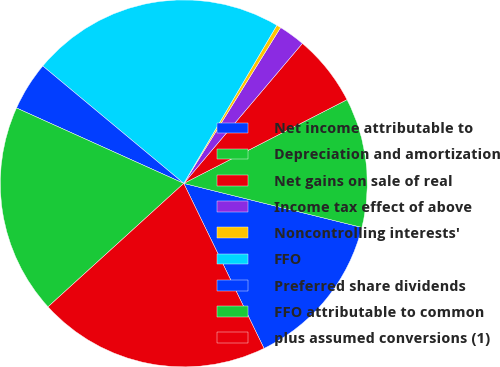Convert chart. <chart><loc_0><loc_0><loc_500><loc_500><pie_chart><fcel>Net income attributable to<fcel>Depreciation and amortization<fcel>Net gains on sale of real<fcel>Income tax effect of above<fcel>Noncontrolling interests'<fcel>FFO<fcel>Preferred share dividends<fcel>FFO attributable to common<fcel>plus assumed conversions (1)<nl><fcel>13.94%<fcel>11.4%<fcel>6.27%<fcel>2.34%<fcel>0.38%<fcel>22.42%<fcel>4.31%<fcel>18.49%<fcel>20.46%<nl></chart> 